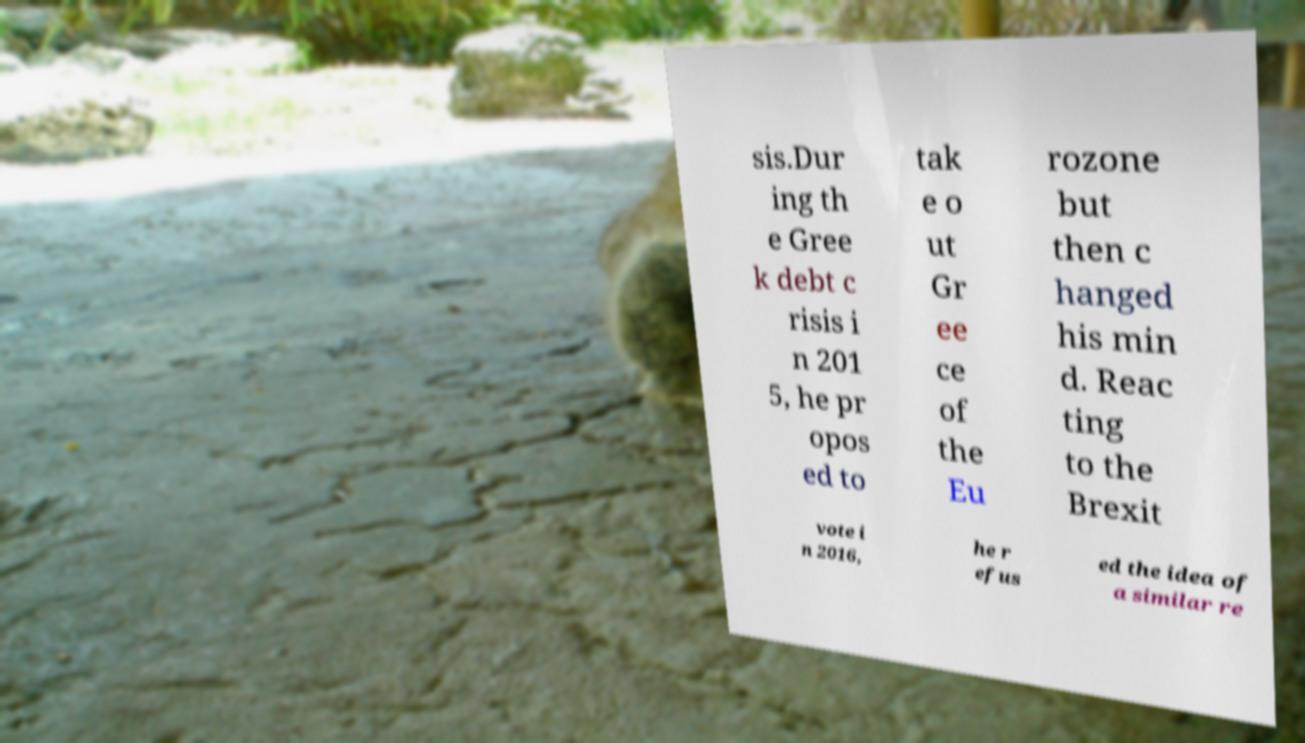I need the written content from this picture converted into text. Can you do that? sis.Dur ing th e Gree k debt c risis i n 201 5, he pr opos ed to tak e o ut Gr ee ce of the Eu rozone but then c hanged his min d. Reac ting to the Brexit vote i n 2016, he r efus ed the idea of a similar re 